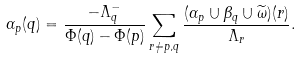<formula> <loc_0><loc_0><loc_500><loc_500>\alpha _ { p } ( q ) = \frac { - \Lambda _ { q } ^ { - } } { \Phi ( q ) - \Phi ( p ) } \sum _ { r \neq p , q } \frac { ( \alpha _ { p } \cup \beta _ { q } \cup \widetilde { \omega } ) ( r ) } { \Lambda _ { r } } .</formula> 